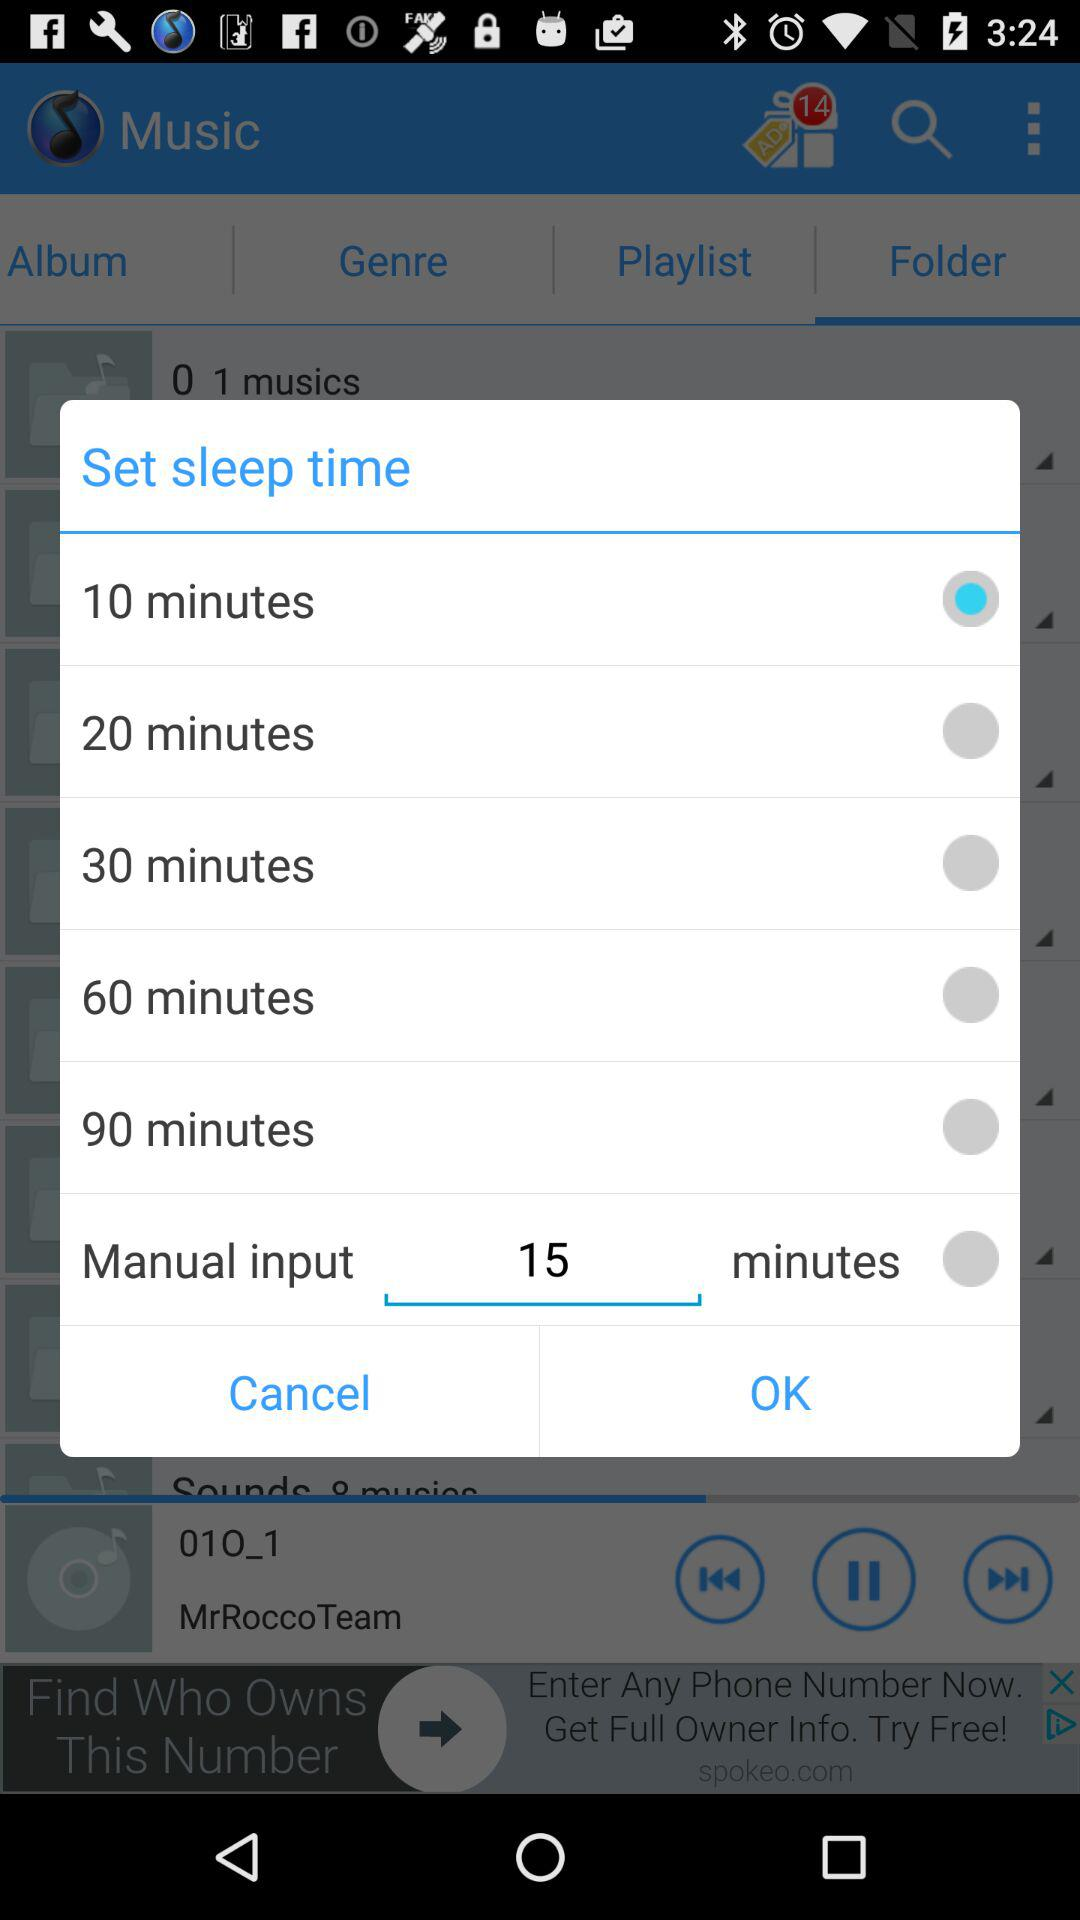Is "20 minutes" selected or not? "20 minutes" is not selected. 